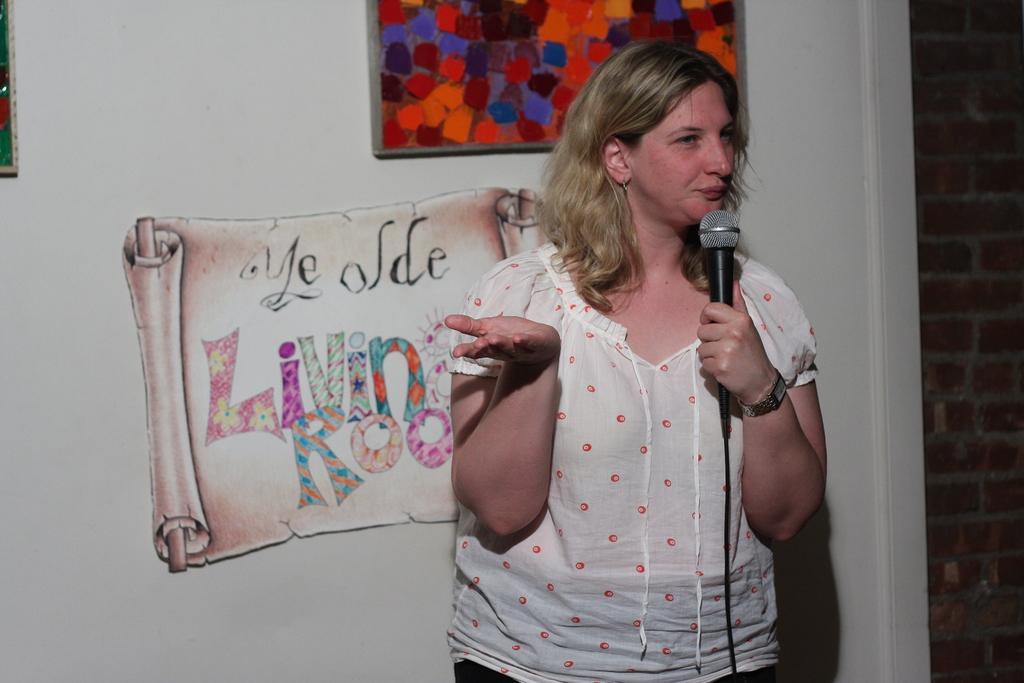How would you summarize this image in a sentence or two? In a picture there is one woman in the center of it holding a microphone and wearing a white shirt, behind her there is wall with some paintings written in the text and one photo, beside that there is one brick wall and she is wearing a watch. 